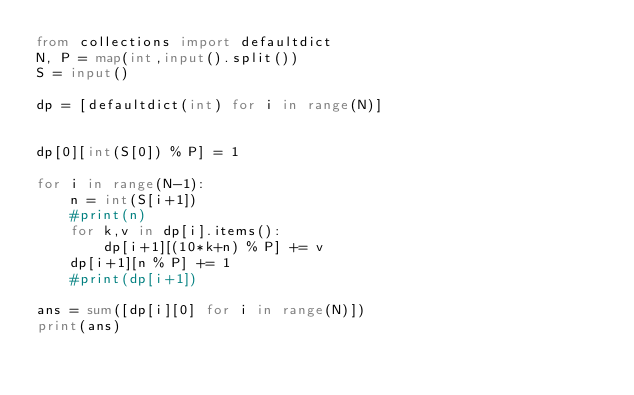Convert code to text. <code><loc_0><loc_0><loc_500><loc_500><_Python_>from collections import defaultdict
N, P = map(int,input().split())
S = input()

dp = [defaultdict(int) for i in range(N)]


dp[0][int(S[0]) % P] = 1

for i in range(N-1):
    n = int(S[i+1])
    #print(n)
    for k,v in dp[i].items():
        dp[i+1][(10*k+n) % P] += v
    dp[i+1][n % P] += 1
    #print(dp[i+1])

ans = sum([dp[i][0] for i in range(N)])
print(ans)


</code> 